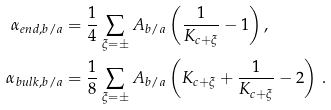<formula> <loc_0><loc_0><loc_500><loc_500>\alpha _ { e n d , b / a } & = \frac { 1 } { 4 } \sum _ { \xi = \pm } A _ { b / a } \left ( \frac { 1 } { K _ { c + \xi } } - 1 \right ) , \\ \alpha _ { b u l k , b / a } & = \frac { 1 } { 8 } \sum _ { \xi = \pm } A _ { b / a } \left ( K _ { c + \xi } + \frac { 1 } { K _ { c + \xi } } - 2 \right ) \, .</formula> 